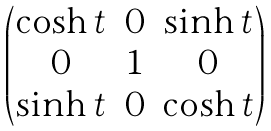<formula> <loc_0><loc_0><loc_500><loc_500>\begin{pmatrix} \cosh t & 0 & \sinh t \\ 0 & 1 & 0 \\ \sinh t & 0 & \cosh t \end{pmatrix}</formula> 